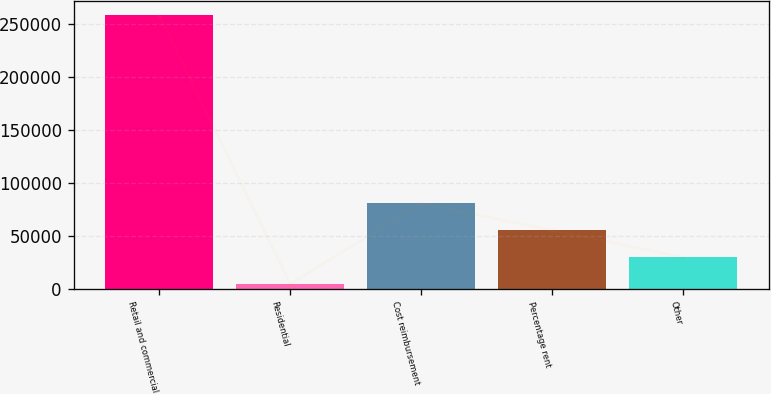Convert chart to OTSL. <chart><loc_0><loc_0><loc_500><loc_500><bar_chart><fcel>Retail and commercial<fcel>Residential<fcel>Cost reimbursement<fcel>Percentage rent<fcel>Other<nl><fcel>258126<fcel>4469<fcel>80566.1<fcel>55200.4<fcel>29834.7<nl></chart> 